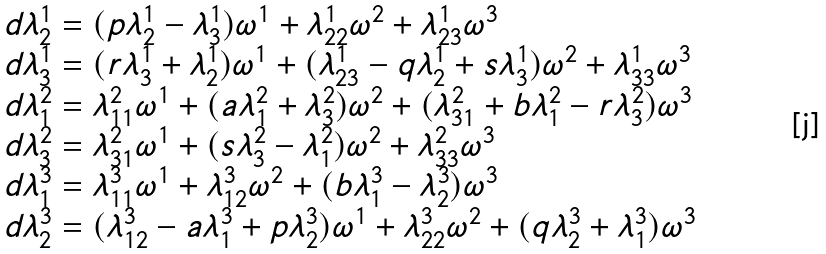Convert formula to latex. <formula><loc_0><loc_0><loc_500><loc_500>\begin{array} { l } d \lambda ^ { 1 } _ { 2 } = ( p \lambda ^ { 1 } _ { 2 } - \lambda ^ { 1 } _ { 3 } ) \omega ^ { 1 } + \lambda ^ { 1 } _ { 2 2 } \omega ^ { 2 } + \lambda ^ { 1 } _ { 2 3 } \omega ^ { 3 } \\ d \lambda ^ { 1 } _ { 3 } = ( r \lambda ^ { 1 } _ { 3 } + \lambda ^ { 1 } _ { 2 } ) \omega ^ { 1 } + ( \lambda ^ { 1 } _ { 2 3 } - q \lambda ^ { 1 } _ { 2 } + s \lambda ^ { 1 } _ { 3 } ) \omega ^ { 2 } + \lambda ^ { 1 } _ { 3 3 } \omega ^ { 3 } \\ d \lambda ^ { 2 } _ { 1 } = \lambda ^ { 2 } _ { 1 1 } \omega ^ { 1 } + ( a \lambda ^ { 2 } _ { 1 } + \lambda ^ { 2 } _ { 3 } ) \omega ^ { 2 } + ( \lambda ^ { 2 } _ { 3 1 } + b \lambda ^ { 2 } _ { 1 } - r \lambda ^ { 2 } _ { 3 } ) \omega ^ { 3 } \\ d \lambda ^ { 2 } _ { 3 } = \lambda ^ { 2 } _ { 3 1 } \omega ^ { 1 } + ( s \lambda ^ { 2 } _ { 3 } - \lambda ^ { 2 } _ { 1 } ) \omega ^ { 2 } + \lambda ^ { 2 } _ { 3 3 } \omega ^ { 3 } \\ d \lambda ^ { 3 } _ { 1 } = \lambda ^ { 3 } _ { 1 1 } \omega ^ { 1 } + \lambda ^ { 3 } _ { 1 2 } \omega ^ { 2 } + ( b \lambda ^ { 3 } _ { 1 } - \lambda ^ { 3 } _ { 2 } ) \omega ^ { 3 } \\ d \lambda ^ { 3 } _ { 2 } = ( \lambda ^ { 3 } _ { 1 2 } - a \lambda ^ { 3 } _ { 1 } + p \lambda ^ { 3 } _ { 2 } ) \omega ^ { 1 } + \lambda ^ { 3 } _ { 2 2 } \omega ^ { 2 } + ( q \lambda ^ { 3 } _ { 2 } + \lambda ^ { 3 } _ { 1 } ) \omega ^ { 3 } \end{array}</formula> 